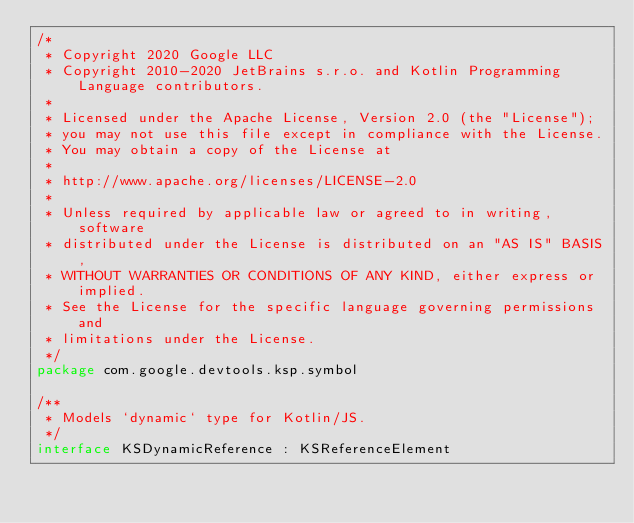Convert code to text. <code><loc_0><loc_0><loc_500><loc_500><_Kotlin_>/*
 * Copyright 2020 Google LLC
 * Copyright 2010-2020 JetBrains s.r.o. and Kotlin Programming Language contributors.
 *
 * Licensed under the Apache License, Version 2.0 (the "License");
 * you may not use this file except in compliance with the License.
 * You may obtain a copy of the License at
 *
 * http://www.apache.org/licenses/LICENSE-2.0
 *
 * Unless required by applicable law or agreed to in writing, software
 * distributed under the License is distributed on an "AS IS" BASIS,
 * WITHOUT WARRANTIES OR CONDITIONS OF ANY KIND, either express or implied.
 * See the License for the specific language governing permissions and
 * limitations under the License.
 */
package com.google.devtools.ksp.symbol

/**
 * Models `dynamic` type for Kotlin/JS.
 */
interface KSDynamicReference : KSReferenceElement
</code> 